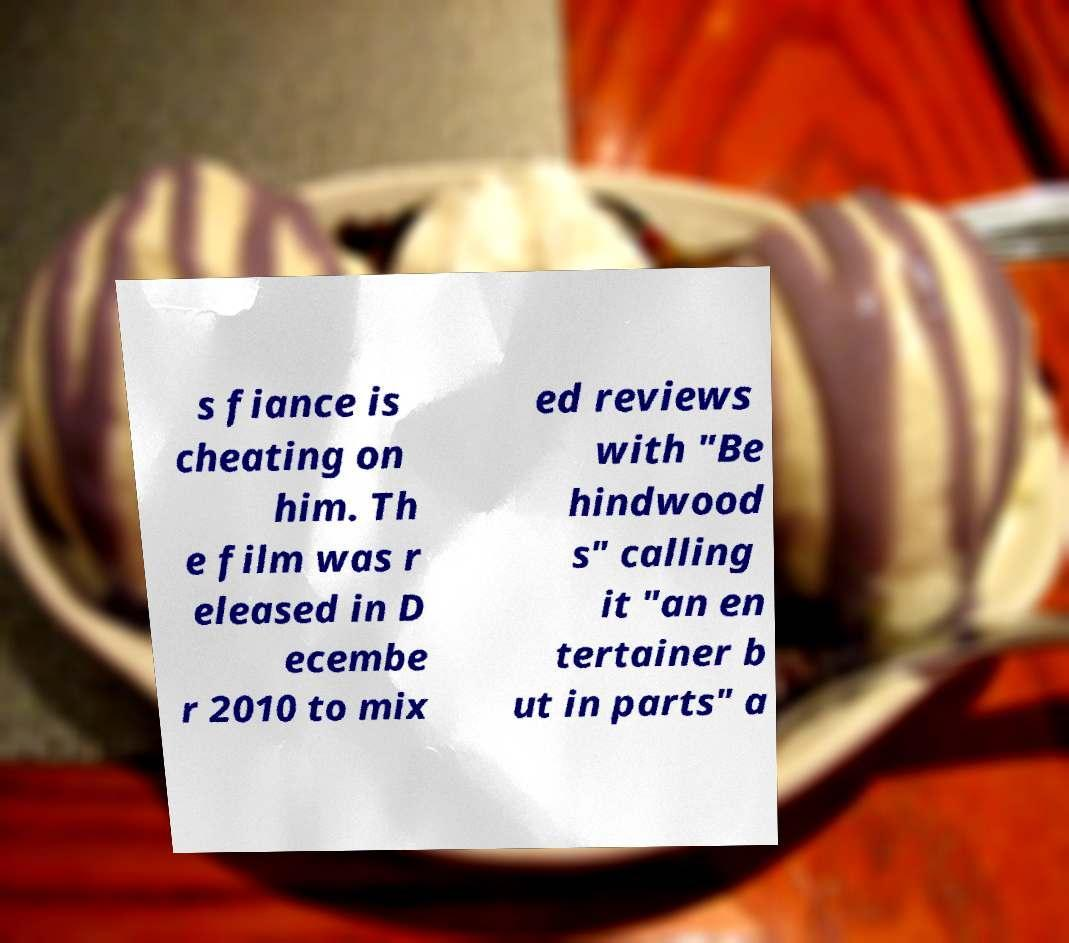Can you read and provide the text displayed in the image?This photo seems to have some interesting text. Can you extract and type it out for me? s fiance is cheating on him. Th e film was r eleased in D ecembe r 2010 to mix ed reviews with "Be hindwood s" calling it "an en tertainer b ut in parts" a 